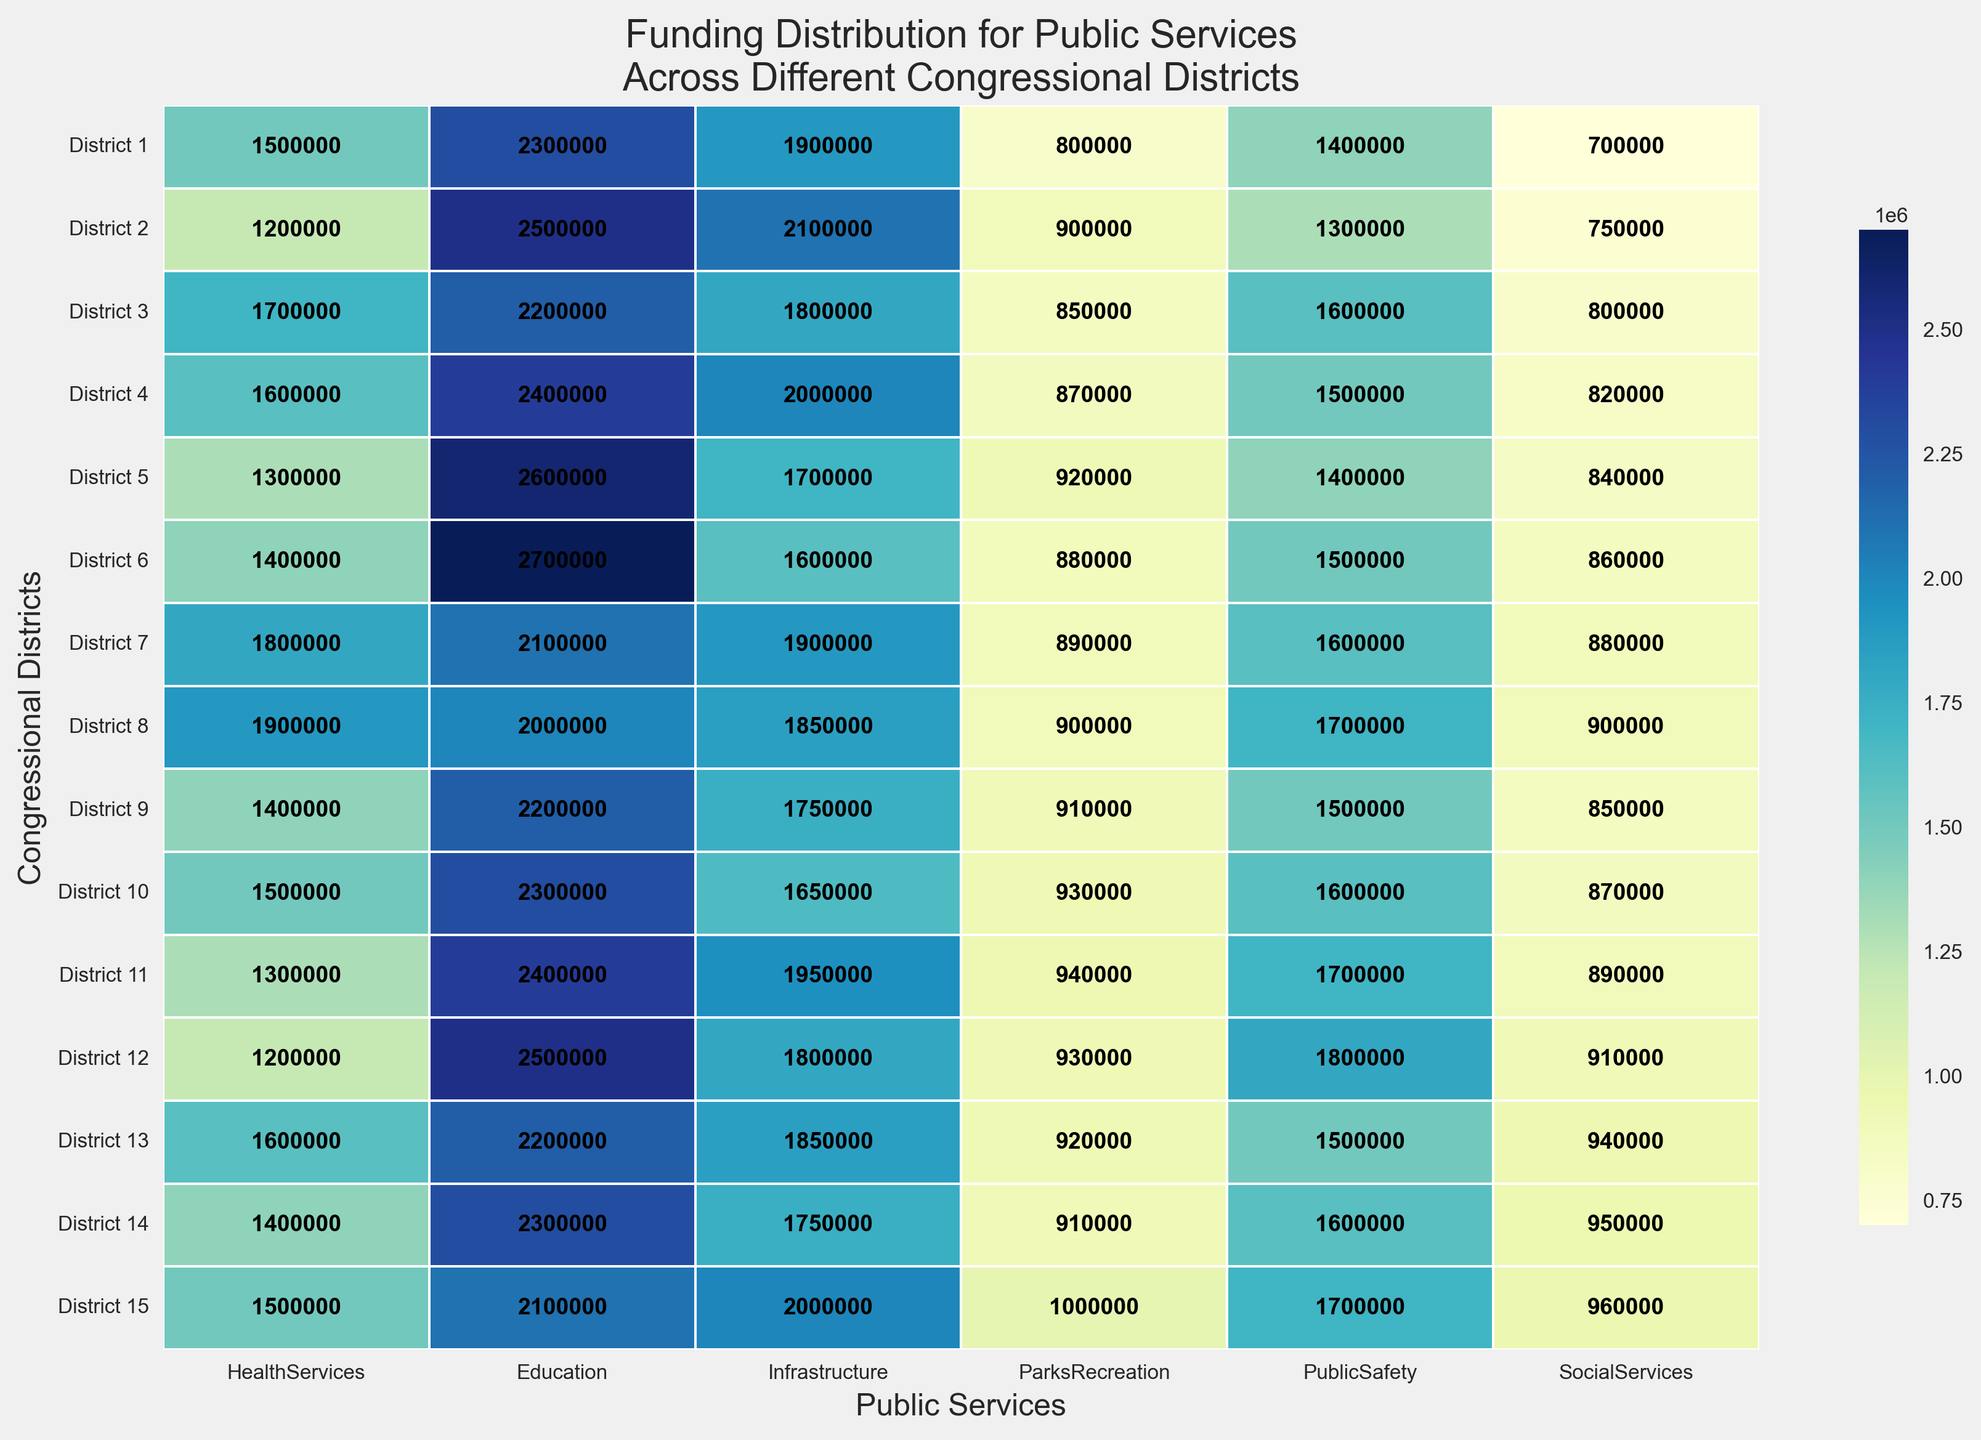What is the difference in funding for Health Services between District 1 and District 3? First, find the funding for Health Services in District 1, which is 1,500,000. Next, find the funding for Health Services in District 3, which is 1,700,000. Subtract the funding of District 1 from District 3 to get the difference: 1,700,000 - 1,500,000 = 200,000.
Answer: 200,000 Which district receives the highest total funding for Education? Examine the values for Education in each district and identify the highest value. District 6 has the highest funding for Education at 2,700,000.
Answer: District 6 Which two districts have the closest funding for Parks and Recreation? Compare the values for Parks and Recreation across all districts to find the ones with the smallest difference. Districts 2 and 8 both have funding values of 900,000, making them the closest.
Answer: District 2 and District 8 What is the average funding for Public Safety across all districts? Add the funding values for Public Safety for all districts: 14,000,000. Divide the total by the number of districts (15): 14,000,000 / 15 ≈ 933,333.33.
Answer: 933,333.33 Which district has the darkest shade of color for Social Services? Identify the district with the highest value for Social Services, as darker shades correspond to higher funding. District 15 has the highest funding at 960,000.
Answer: District 15 How does the funding for Infrastructure compare between District 5 and District 10? Look for the funding values for Infrastructure in District 5 and District 10. District 5 has 1,700,000, and District 10 has 1,650,000. District 5 has slightly higher funding for Infrastructure.
Answer: District 5 If you sum the funding for Health Services and Public Safety in District 11, how much is it? In District 11, Health Services is funded at 1,300,000 and Public Safety at 1,700,000. Their sum is: 1,300,000 + 1,700,000 = 3,000,000.
Answer: 3,000,000 Which service receives the least funding in District 7? Identify the smallest funding value for each service in District 7. Parks and Recreation receives the least funding at 890,000.
Answer: Parks and Recreation 